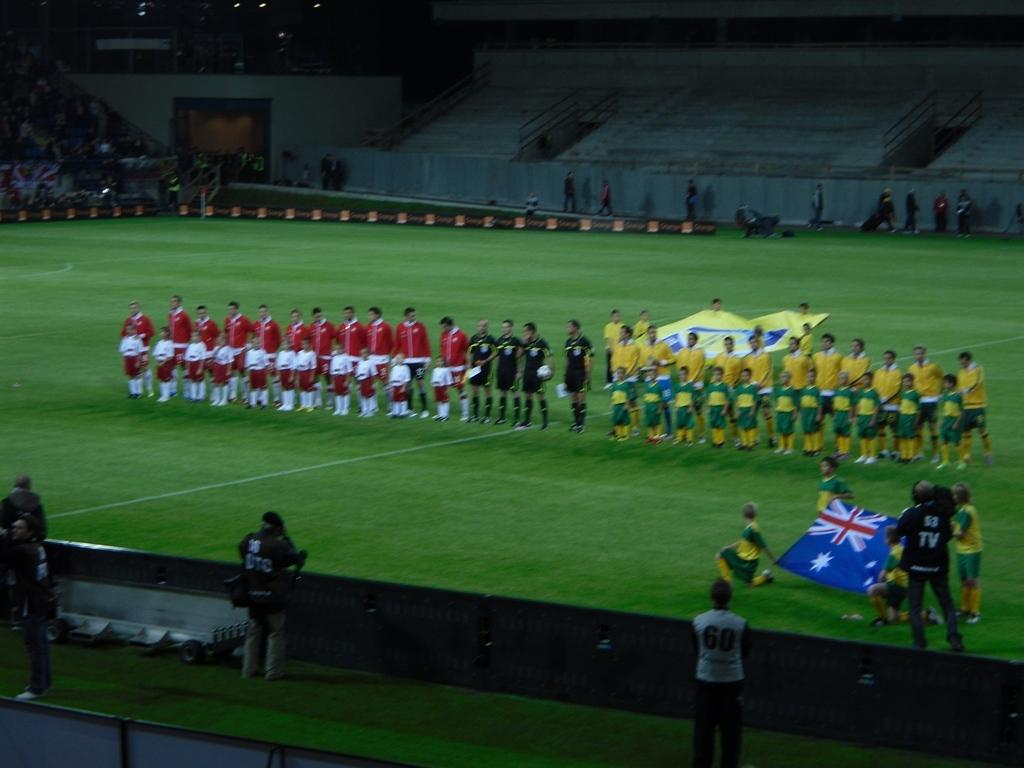<image>
Relay a brief, clear account of the picture shown. a field with two teams standing in line and a man in the corner with TV written on his back filming 